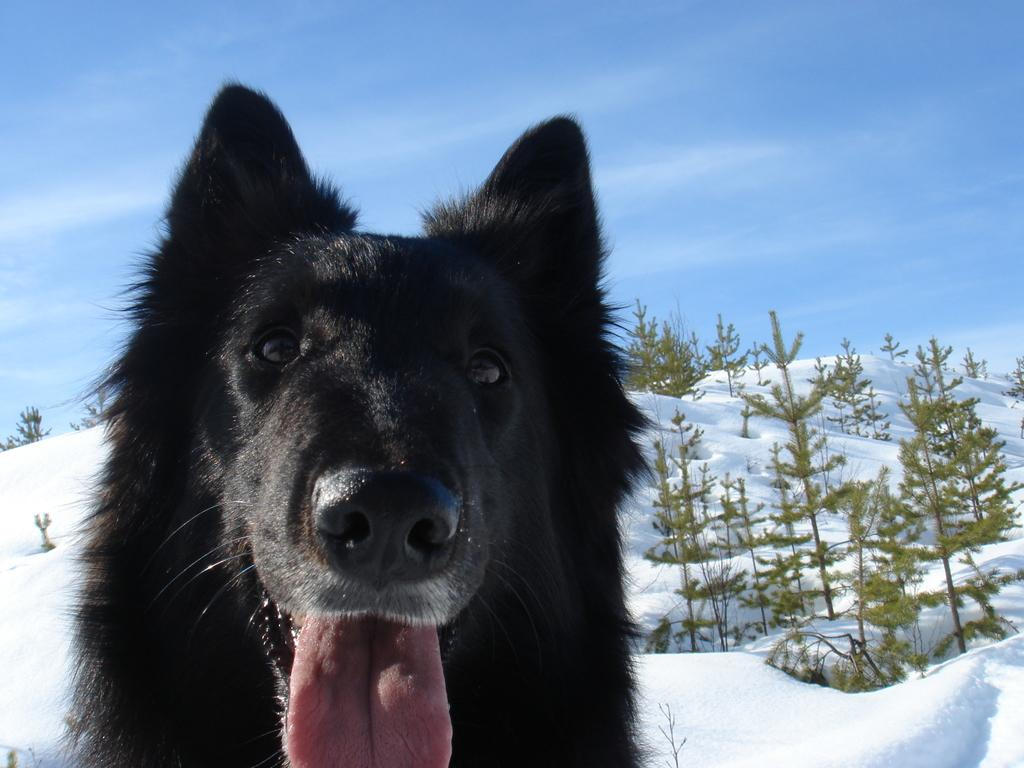What type of animal can be seen in the image? There is a dog in the image. What is covering the ground in the image? The ground is covered in snow. What type of vegetation is present in the image? There are trees in the image. What can be seen in the background of the image? The sky is visible in the background of the image. What type of music instrument is the dog playing in the image? There is no music instrument present in the image, and the dog is not playing any instrument. 